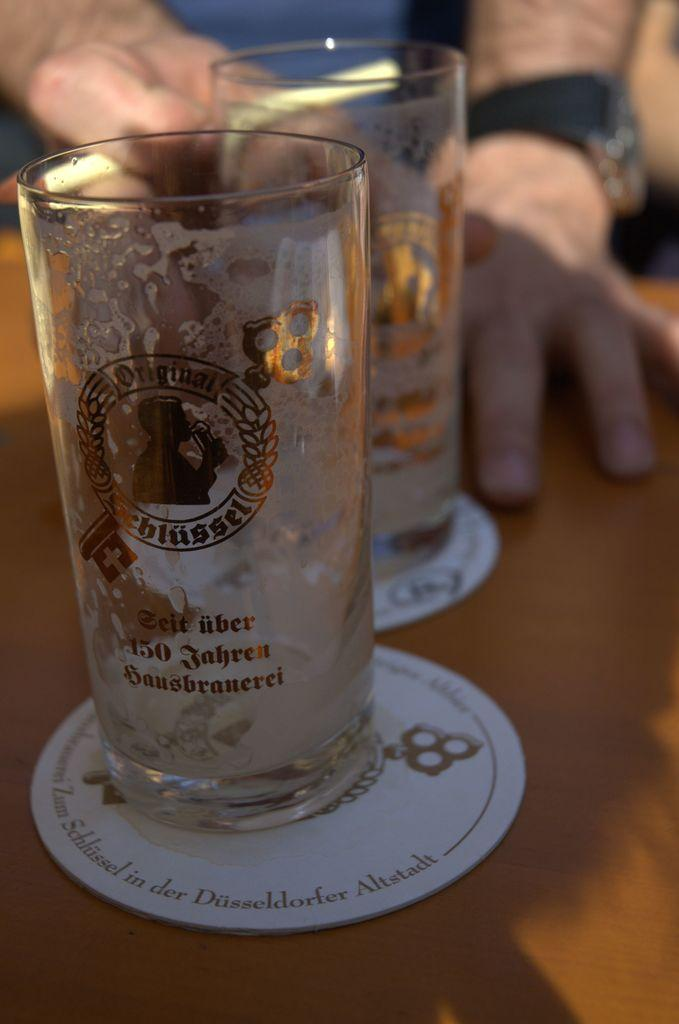What piece of furniture is present in the image? There is a table in the image. What objects are on the table? There are two glasses on the table. Whose hands are visible in the image? The person's hands are visible in the image. What accessory is the person wearing on one hand? The person is wearing a wristwatch on one hand. What type of print is visible on the person's shirt in the image? There is no information about the person's shirt in the provided facts, so we cannot determine if there is a print visible. 